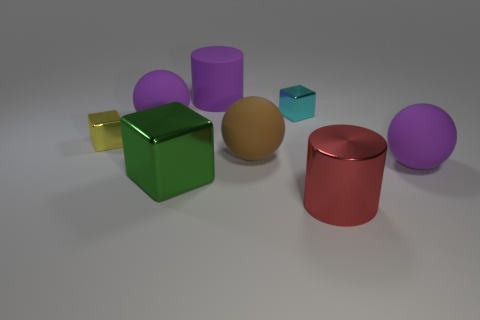What color is the metallic cylinder that is the same size as the rubber cylinder?
Your answer should be compact. Red. How many objects are tiny cyan metallic objects that are to the left of the red metallic object or shiny objects that are in front of the green metal cube?
Keep it short and to the point. 2. What number of objects are either tiny cyan blocks or small blocks?
Offer a terse response. 2. There is a object that is both on the left side of the green block and behind the tiny yellow metallic cube; what is its size?
Your response must be concise. Large. What number of tiny yellow objects have the same material as the green thing?
Give a very brief answer. 1. There is a large thing that is made of the same material as the big green cube; what is its color?
Keep it short and to the point. Red. There is a large matte ball that is to the left of the purple cylinder; does it have the same color as the large rubber cylinder?
Offer a very short reply. Yes. There is a large purple ball on the left side of the tiny cyan block; what material is it?
Your response must be concise. Rubber. Is the number of small cyan metallic objects right of the green thing the same as the number of large brown matte things?
Make the answer very short. Yes. How many matte balls have the same color as the rubber cylinder?
Keep it short and to the point. 2. 